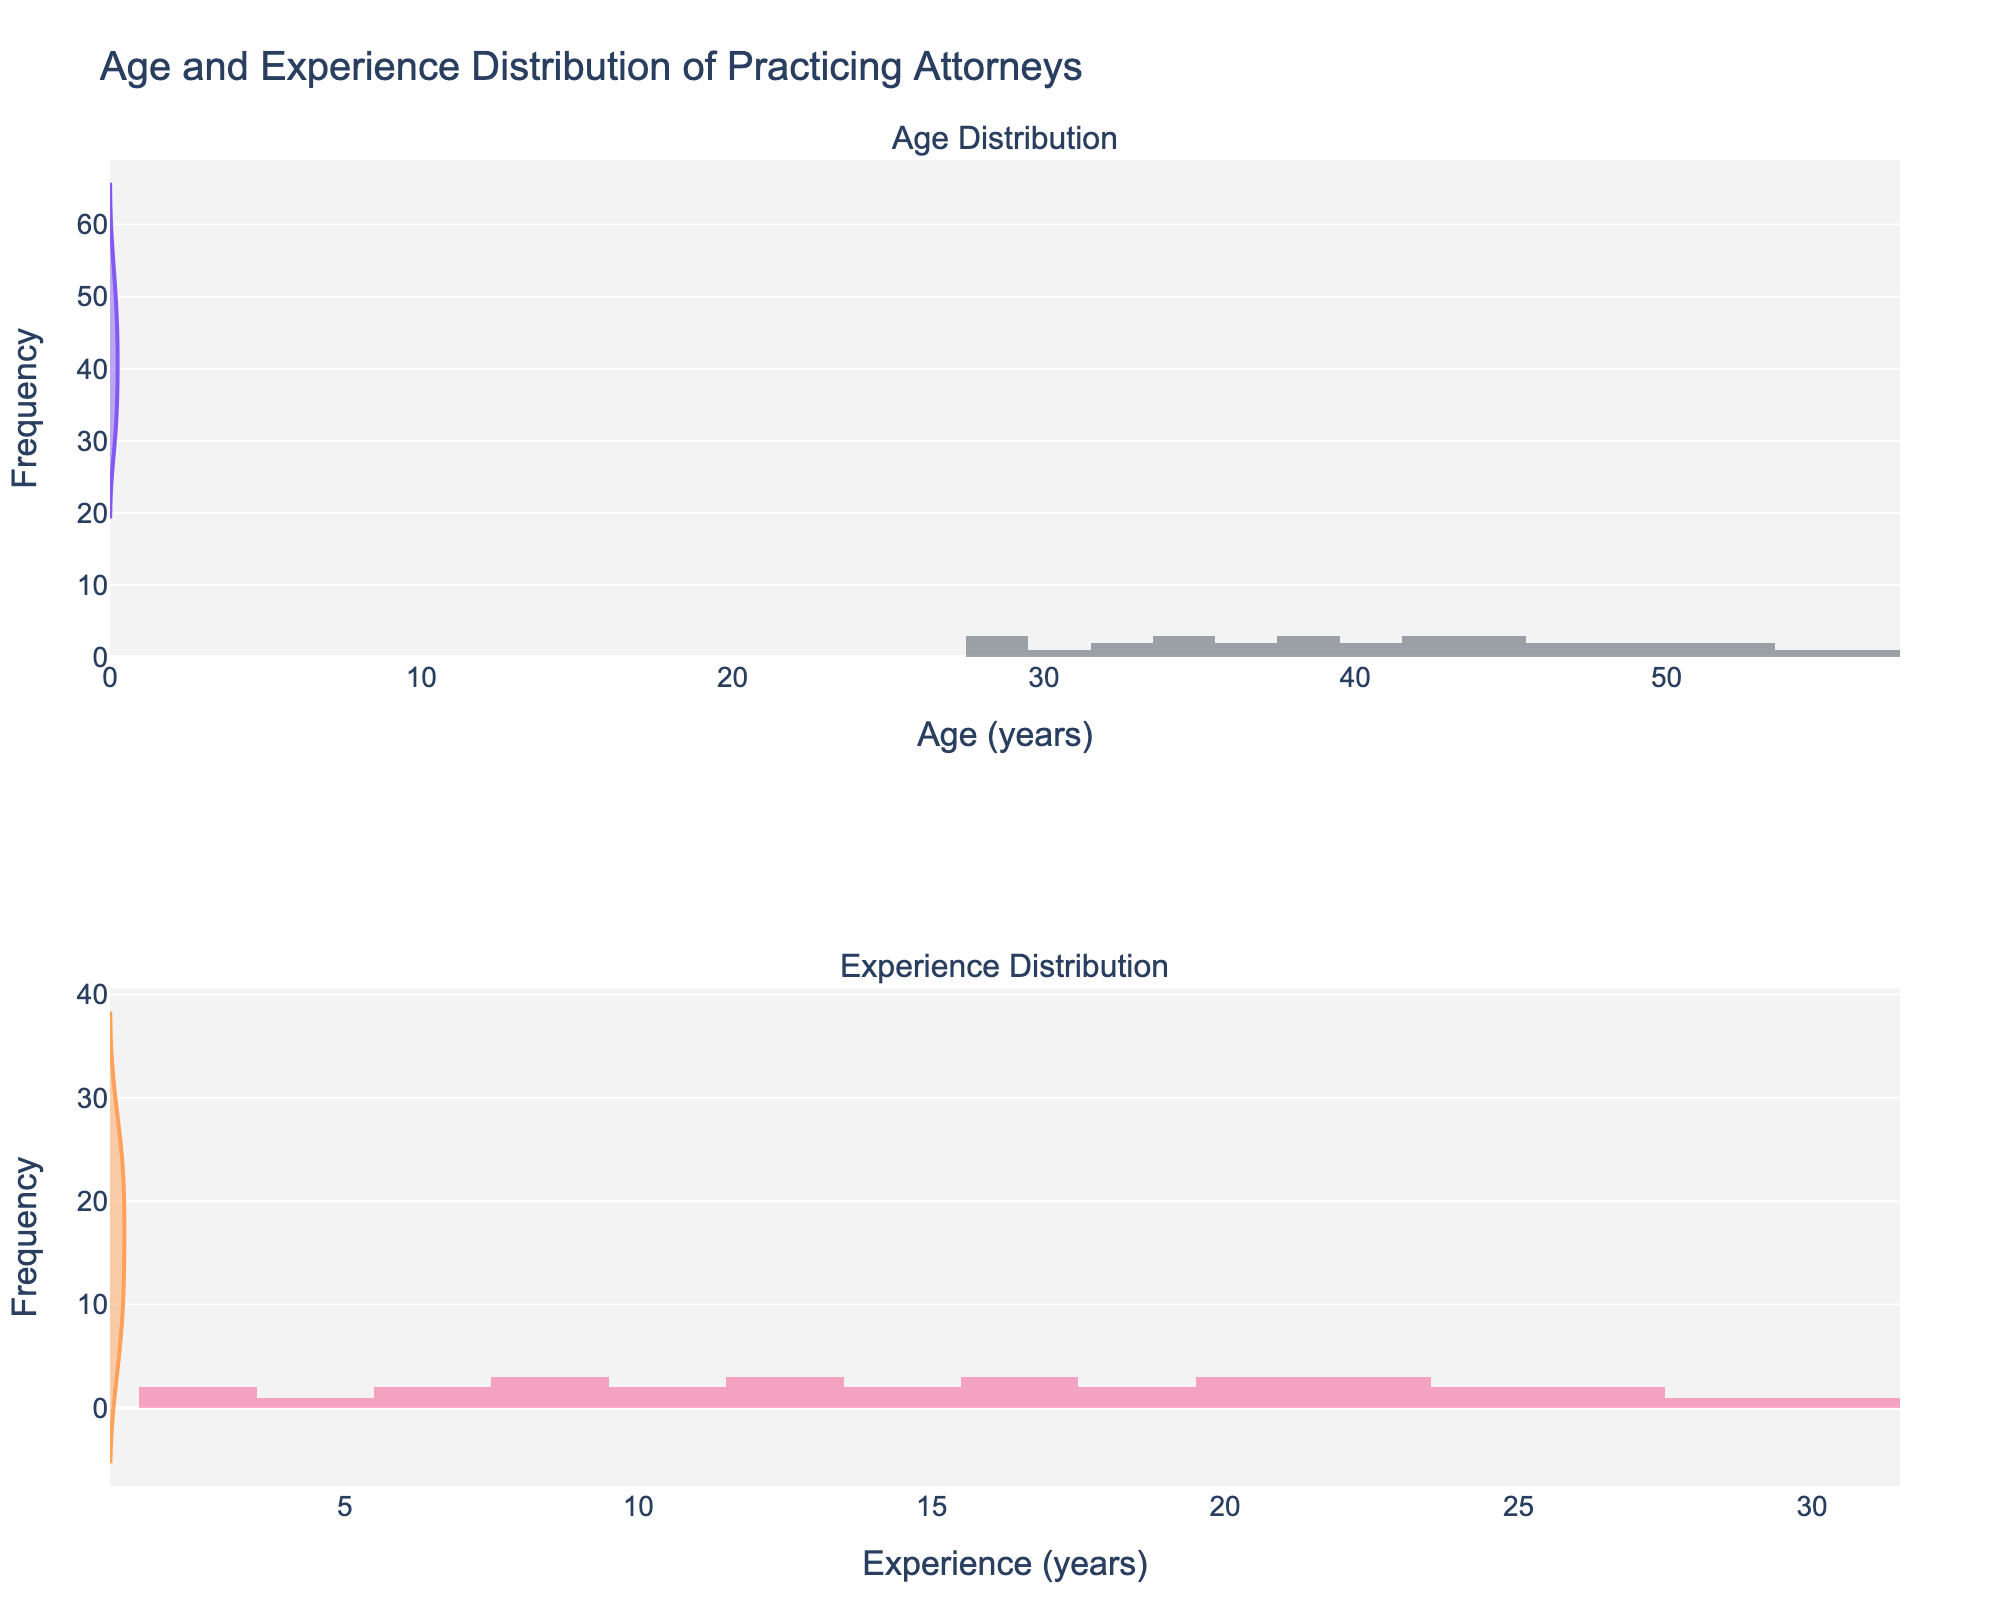What is the title of the figure? The title is displayed at the top of the figure. It provides an overview of what the figure represents. The title reads "Age and Experience Distribution of Practicing Attorneys".
Answer: Age and Experience Distribution of Practicing Attorneys How many subplots are there in the figure? By observing the figure, it is divided into two distinct parts, both vertically aligned. This structure indicates the presence of two subplots.
Answer: 2 What do the x-axes represent in the two subplots? The x-axes are labeled to denote the measurement of interest in each subplot. The first subplot's x-axis represents "Age (years)", while the second subplot's x-axis represents "Experience (years)".
Answer: Age (years) and Experience (years) Which state shows the highest frequency of attorneys in the age distribution? By looking at the histogram in the age distribution subplot, one can examine the tallest bar. The highest frequency can be identified there, representing the state with the most attorneys within a specific age range.
Answer: Varies based on exact counts within the age distribution What color is used for the violin plot in the age distribution subplot? The violin plot in the age distribution subplot is visually distinguishable by its unique color, which is a shade of purple (but do not include terms like RGB, just describe the hue).
Answer: Purple What is the approximate median age of practicing attorneys shown in the age distribution violin plot? By examining the density and shape of the purple violin plot in the age distribution subplot, the median age can be inferred where the distribution is balanced around the center.
Answer: Varies, approximate based on the plot Is there a broader age distribution or experience distribution among practicing attorneys? By visually comparing the spread and shapes of the violin plots in both subplots, one can observe which distribution covers a wider range of values.
Answer: Broader Age Distribution Which subplot shows a higher density of practicing attorneys towards the lower end of the scale? By observing the height and concentration of the histogram bars in each subplot, it is apparent which subplot has a greater frequency of data points towards the lower end (left side).
Answer: Experience Distribution What is the age range with the highest frequency of practicing attorneys? By examining the height of the bars in the age histogram in the first subplot, the age range with the highest frequency can be determined. The highest bar represents the most common age range.
Answer: Varies based on highest bars How does the age distribution compare to the experience distribution for a similar range, say 20-30 years? By comparing the age histogram for the range of 20-30 years to the experience histogram for a similar range, we can observe the frequency and density of each distribution in that specific range.
Answer: Different distributions based on figure 